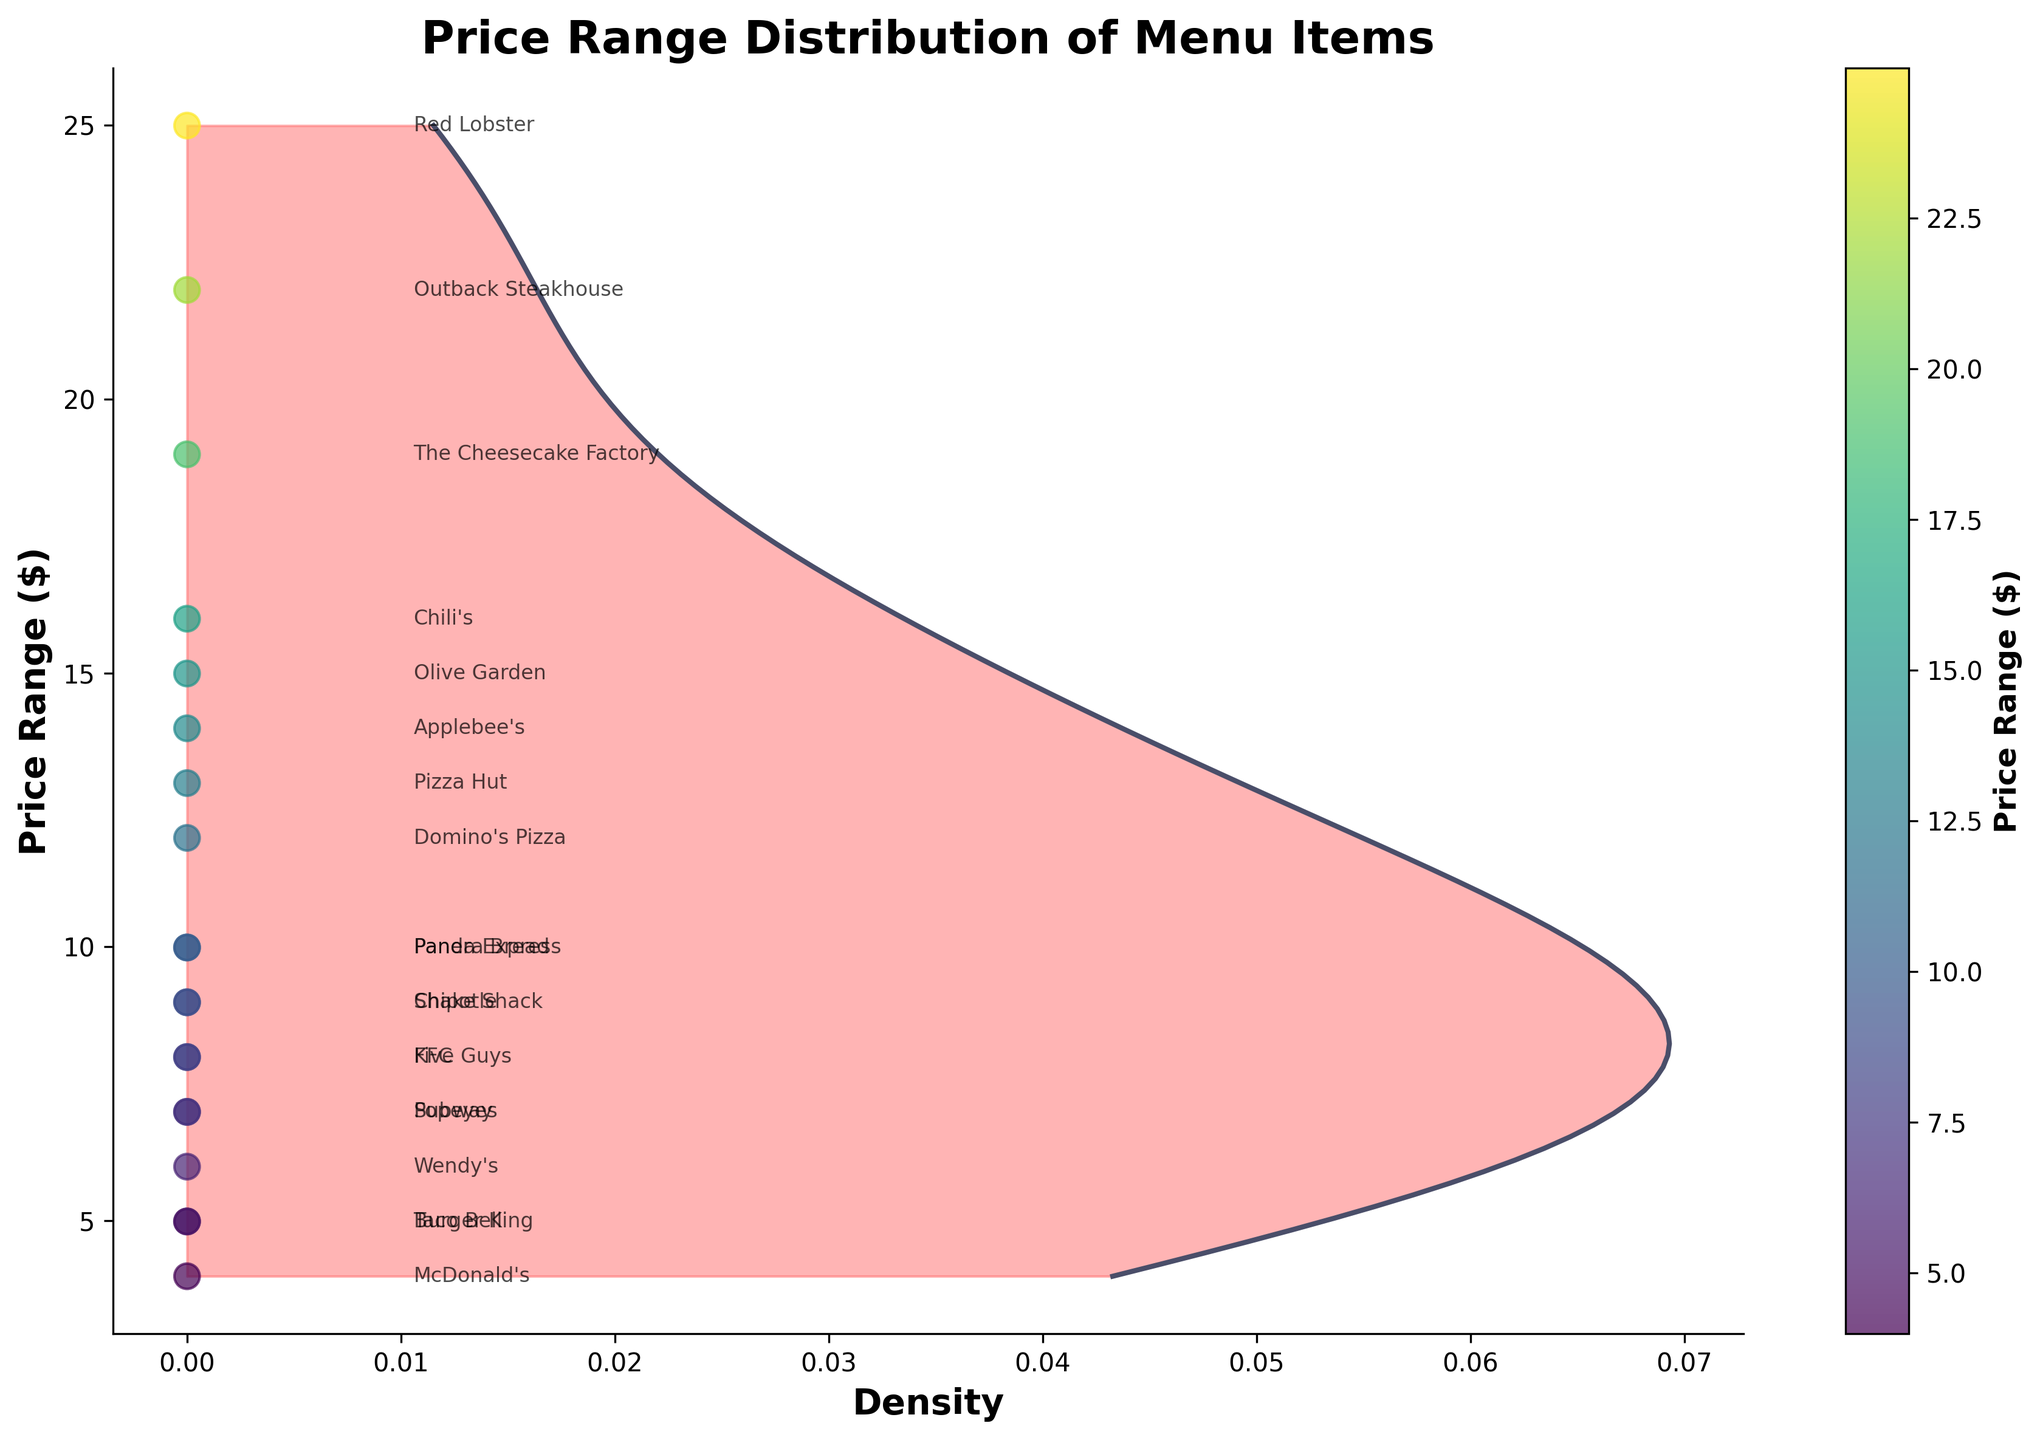what's the title of the plot? The title is shown at the top of the figure.
Answer: Price Range Distribution of Menu Items what does the x-axis represent? The x-axis is labeled "Density," indicating it represents the density of the price ranges.
Answer: Density what is the price range of the menu items from McDonald's? The price range for McDonald's is shown in the scatter plot annotations.
Answer: 3.99 how many restaurants have their price range at $9.99? The annotations show that Panera Bread and Panda Express both have their price range at $9.99.
Answer: 2 which cuisine type generally has the lowest price range? Fast Food restaurants like McDonald's, Wendy's, and Burger King have the lowest price ranges among the options annotated.
Answer: Fast Food what is the maximum price range observed in the plot? The top point in the scatter plot annotations indicates that Red Lobster has a price range of $24.99.
Answer: 24.99 what range of prices has the highest density? The curve peaks indicate the highest density of prices around the range of $7-$10.
Answer: $7-$10 which restaurant has a price range closest to $20? According to the annotations, Outback Steakhouse is closest to $20 with a price range of $21.99.
Answer: Outback Steakhouse compare the price range of Olive Garden and Applebee's. Which one is higher? The scatter plot annotations show that Olive Garden's price range is $14.99, while Applebee's is $13.99.
Answer: Olive Garden is the price range of Taco Bell higher or lower than Subway? Taco Bell's price range is $4.99, which is lower than Subway's price range of $6.99 according to the annotations.
Answer: Lower 